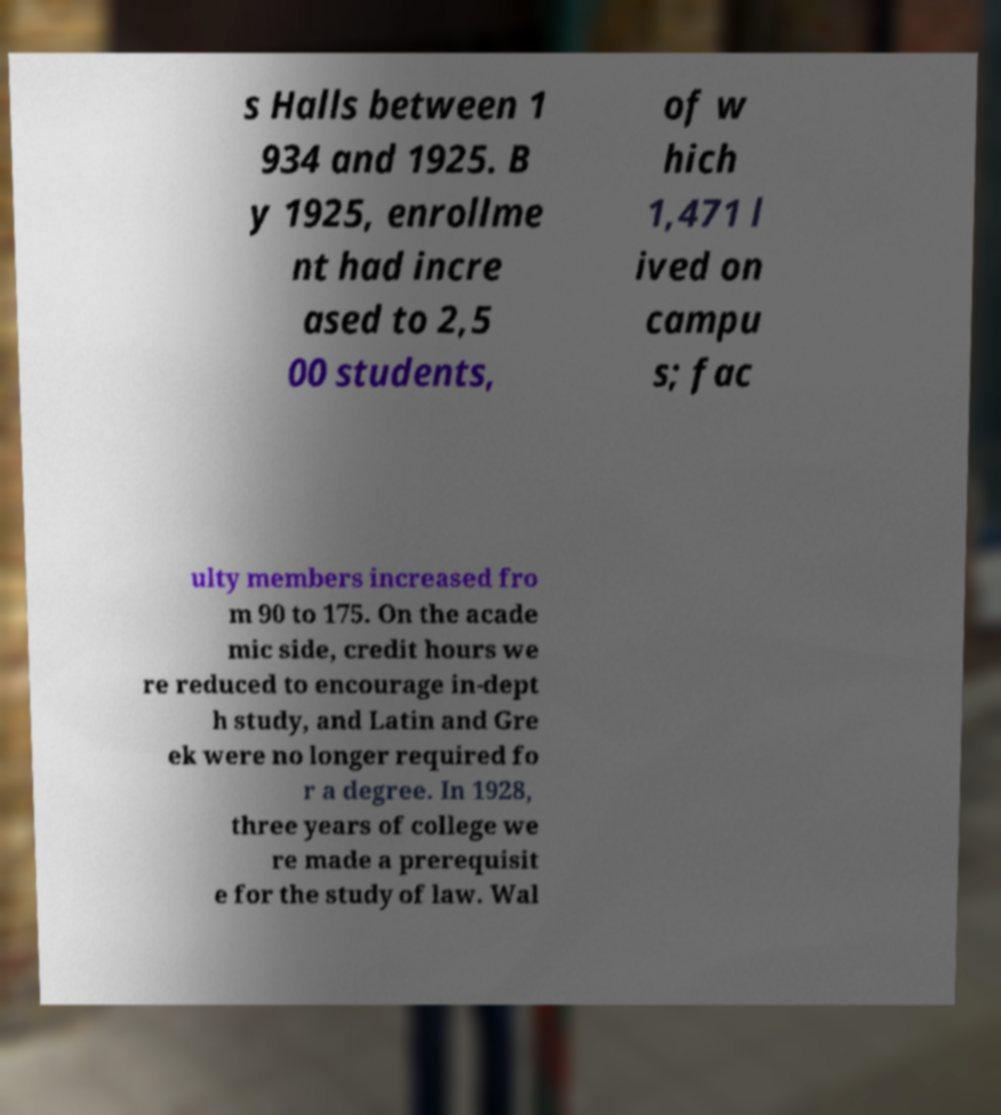For documentation purposes, I need the text within this image transcribed. Could you provide that? s Halls between 1 934 and 1925. B y 1925, enrollme nt had incre ased to 2,5 00 students, of w hich 1,471 l ived on campu s; fac ulty members increased fro m 90 to 175. On the acade mic side, credit hours we re reduced to encourage in-dept h study, and Latin and Gre ek were no longer required fo r a degree. In 1928, three years of college we re made a prerequisit e for the study of law. Wal 